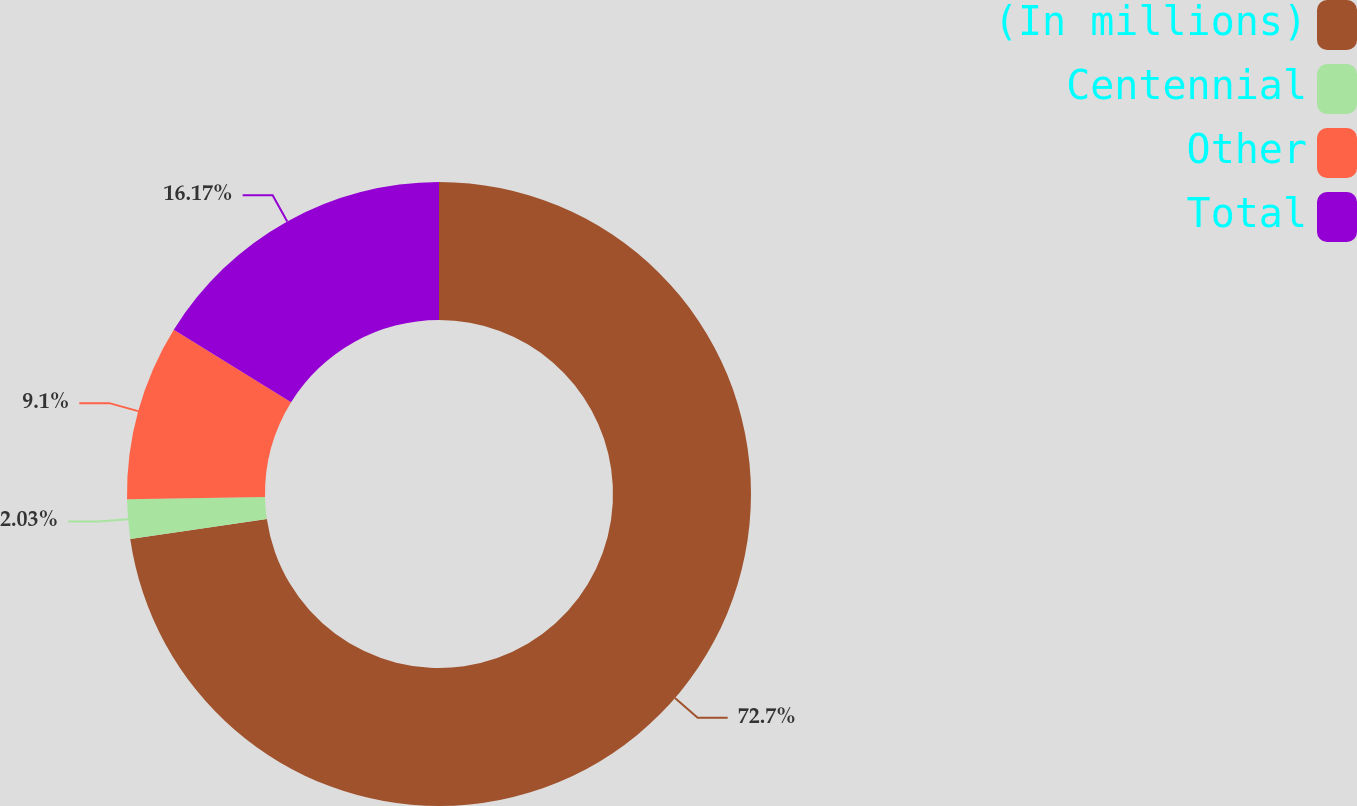Convert chart to OTSL. <chart><loc_0><loc_0><loc_500><loc_500><pie_chart><fcel>(In millions)<fcel>Centennial<fcel>Other<fcel>Total<nl><fcel>72.7%<fcel>2.03%<fcel>9.1%<fcel>16.17%<nl></chart> 